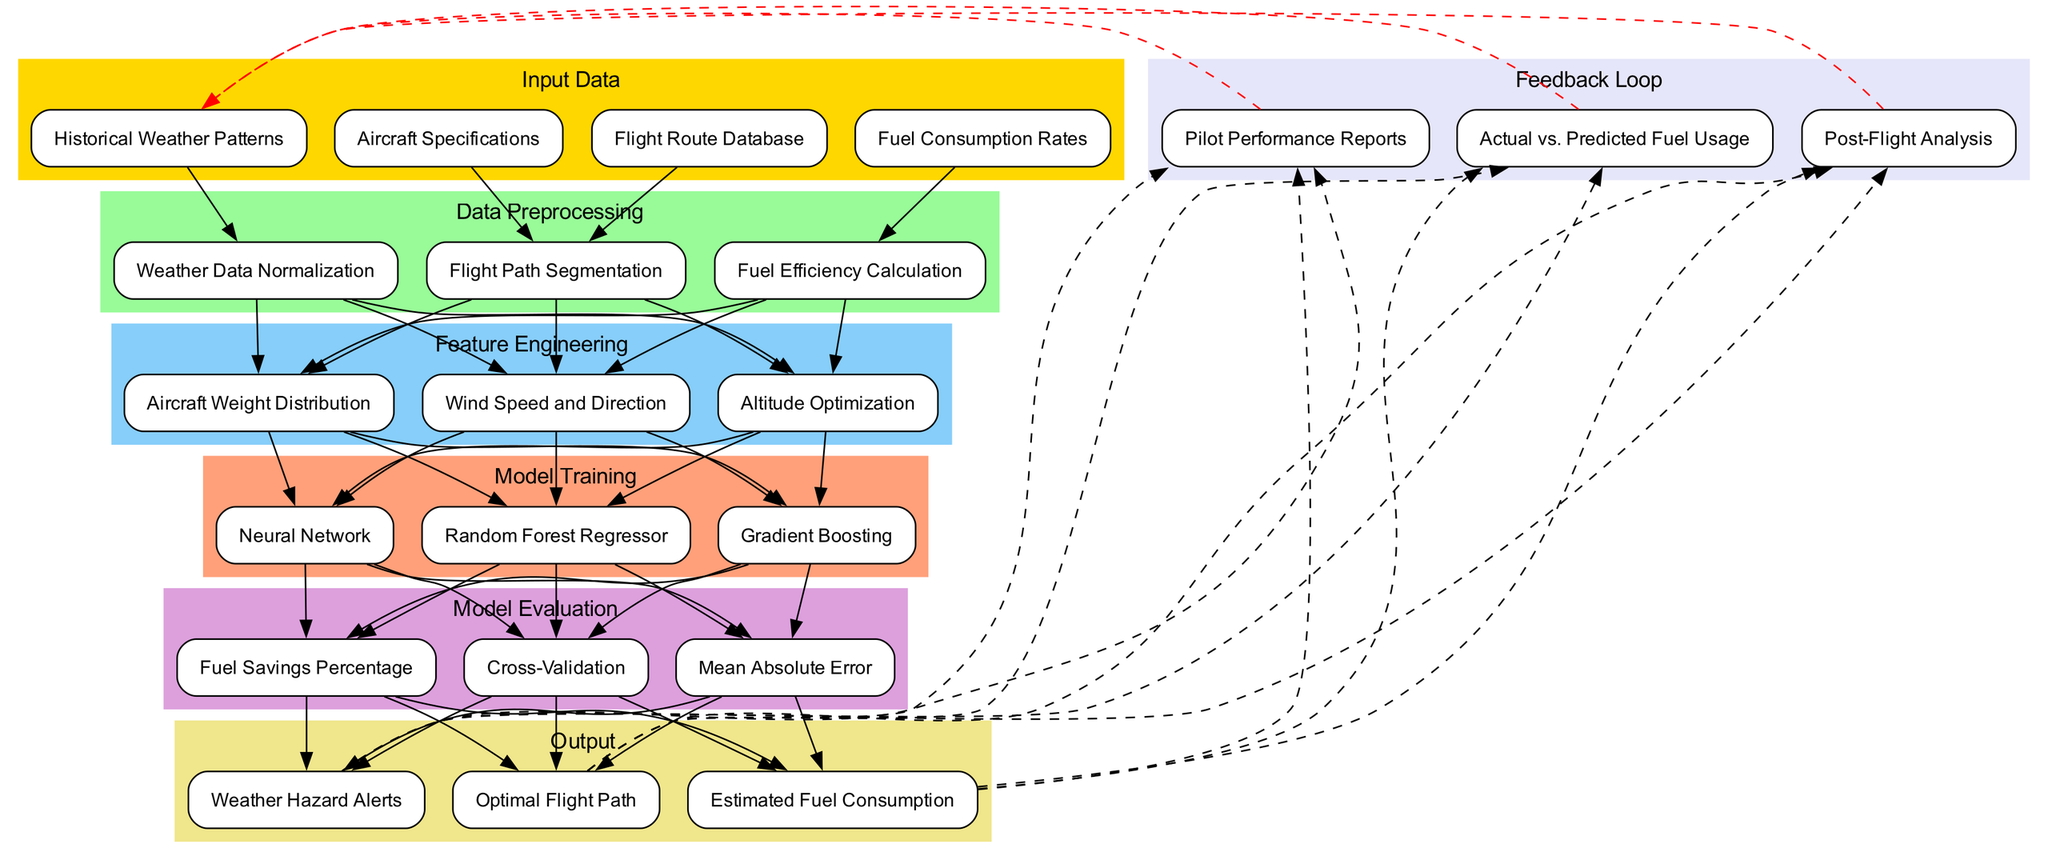What are the input data sources in the diagram? The diagram lists four specific input data sources: Historical Weather Patterns, Aircraft Specifications, Fuel Consumption Rates, and Flight Route Database. Each of these nodes is clearly defined in the input data section.
Answer: Historical Weather Patterns, Aircraft Specifications, Fuel Consumption Rates, Flight Route Database How many types of models are trained in the model training section? The model training section contains three distinct models: Random Forest Regressor, Gradient Boosting, and Neural Network. Counting each of these nodes gives a total of three types of models.
Answer: Three What connects the Fuel Consumption Rates and Fuel Efficiency Calculation nodes? The edge between the Fuel Consumption Rates node and the Fuel Efficiency Calculation node indicates a direct connection; that is, fuel consumption data directly influences the calculation of fuel efficiency.
Answer: An edge Which data preprocessing step is linked to the Wind Speed and Direction feature? The Weather Data Normalization step links to Wind Speed and Direction. The diagram shows this connection indicating that normalizing the weather data directly impacts the feature engineering of wind speed and direction.
Answer: Weather Data Normalization What output is generated after the evaluation phase? The outputs generated post-evaluation include Optimal Flight Path, Estimated Fuel Consumption, and Weather Hazard Alerts. These nodes represent the results from the evaluation phase of the machine learning process.
Answer: Optimal Flight Path, Estimated Fuel Consumption, Weather Hazard Alerts What is the purpose of the feedback loop in the diagram? The feedback loop serves to improve the model iteratively by including Pilot Performance Reports, Actual vs. Predicted Fuel Usage, and Post-Flight Analysis. It closes the cycle by feeding back information to enhance the initial weather patterns.
Answer: Improve model performance Which model has a direct connection to Mean Absolute Error? The Gradient Boosting model has a direct connection to the Mean Absolute Error evaluation method as both nodes are sequentially linked in the model evaluation section.
Answer: Gradient Boosting How many edges are there that connect the feature engineering nodes to the model training nodes? Each feature from the feature engineering section connects to every model in the training section, which means three feature nodes connect to three model nodes, totaling nine edges in that connection.
Answer: Nine Which input data is used to segment flight paths? The Flight Route Database node is specifically used for segmenting flight paths. This connection is displayed in the diagram, indicating how one of the input data sources plays a crucial role in the data preprocessing stage.
Answer: Flight Route Database 